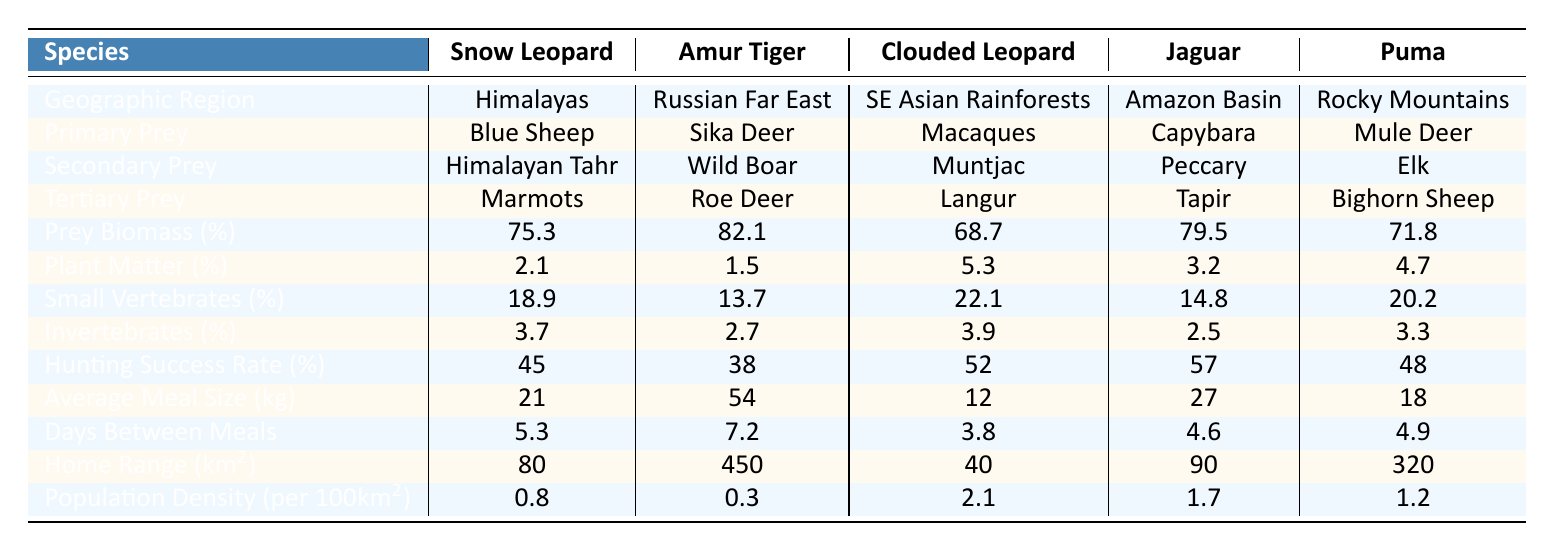What is the primary prey of the Snow Leopard? The Snow Leopard's primary prey is listed in the table under the "Primary Prey" row, corresponding to the "Snow Leopard" column. It is Blue Sheep.
Answer: Blue Sheep Which species has the highest hunting success rate? The "Hunting Success Rate" row shows the success rates for each species. Amur Tiger has a rate of 38%, which is the lowest, while Jaguar has the highest at 57%.
Answer: Jaguar What is the average meal size of the Clouded Leopard in kg? Directly referring to the "Average Meal Size" row for the Clouded Leopard shows the value of 12 kg.
Answer: 12 kg Compare the prey biomass percentages of the Snow Leopard and the Puma. The Prey Biomass percentages are 75.3% for Snow Leopard and 71.8% for Puma. Therefore, Snow Leopard has a higher percentage of prey biomass than Puma.
Answer: Snow Leopard has a higher percentage What is the average prey biomass percentage of all species combined? Calculate the average by summing the prey biomass percentages (75.3 + 82.1 + 68.7 + 79.5 + 71.8) = 377.4, and then divide by the number of species (5): 377.4 / 5 = 75.48%.
Answer: 75.48% Is the proportion of invertebrates in the diet of the Jaguar higher than that of the Amur Tiger? The table shows that Jaguar's invertebrate percentage is 2.5% while the Amur Tiger's is 2.7%, indicating that the Amur Tiger has a higher proportion.
Answer: No For which species does the home range exceed 300 km²? The "Home Range" row shows that the Amur Tiger has a range of 450 km², and the Puma has 320 km². Therefore, both the Amur Tiger and Puma exceed 300 km².
Answer: Amur Tiger and Puma Which species' diet contains the highest percentage of plant matter? Looking at the "Plant Matter Percentage" row, we see that the Clouded Leopard has the highest value of 5.3%.
Answer: Clouded Leopard What is the difference in days between meals for the Jaguar and the Snow Leopard? The "Days Between Meals" for Jaguar is 4.6, and for Snow Leopard it is 5.3. Calculate the difference: 5.3 - 4.6 = 0.7 days.
Answer: 0.7 days Which species has the highest population density per 100 km²? The "Population Density" row indicates the Clouded Leopard at 2.1 individuals per 100 km² has the highest density.
Answer: Clouded Leopard How does the average meal size of the Amur Tiger compare to that of the Snow Leopard? The average meal size for Amur Tiger is 54 kg, while for Snow Leopard it is 21 kg. The Amur Tiger's meal size is larger.
Answer: Amur Tiger's meal size is larger 